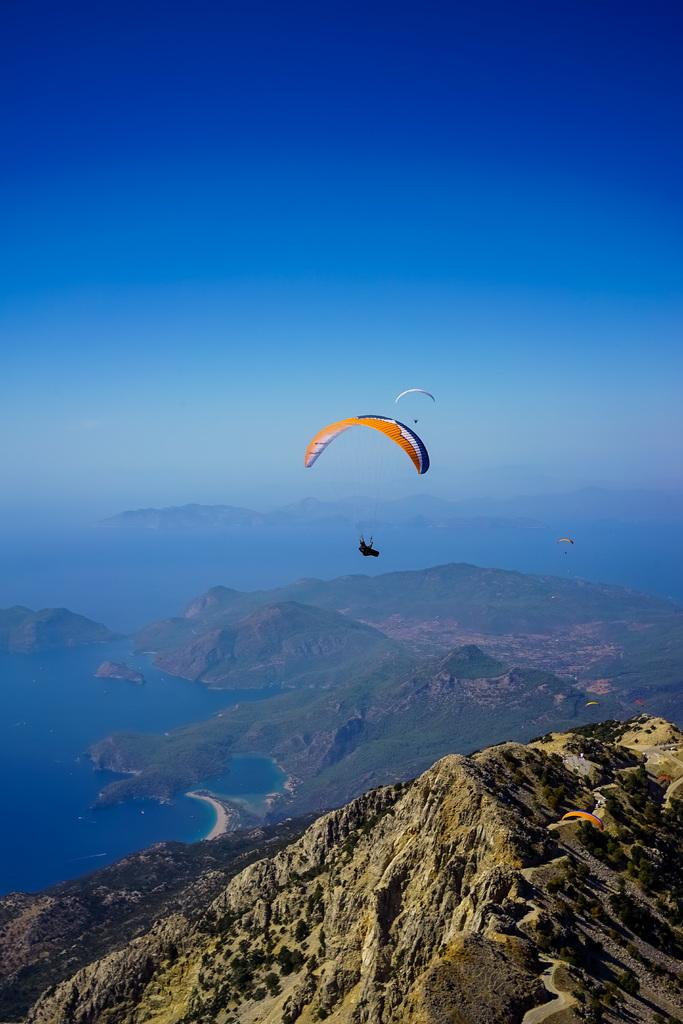What is the person in the image doing? There is a person flying in the air with a parachute in the image. What geographical feature can be seen in the image? There is a mountain in the image. What is located on the left side of the image? There is water on the left side of the image. What part of the natural environment is visible in the image? The sky is visible in the image. What type of pot is being used to rake the water in the image? There is no pot or rake present in the image; it features a person flying with a parachute, a mountain, water, and the sky. 